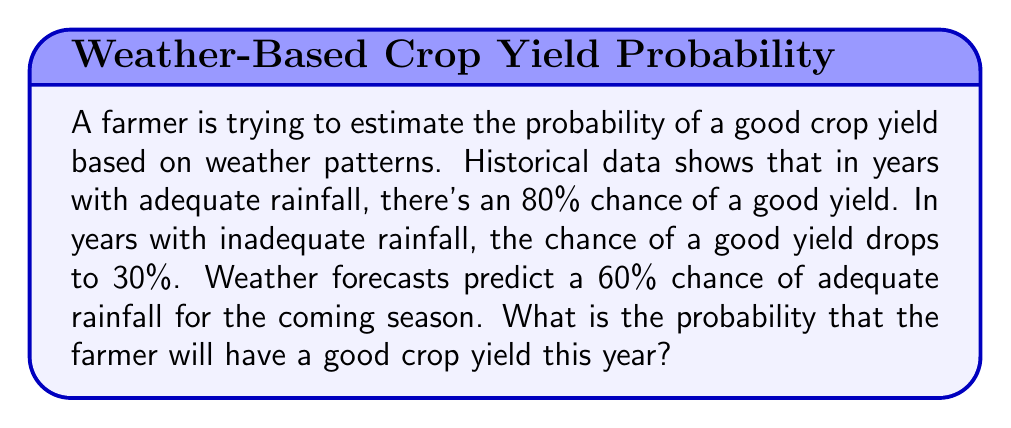What is the answer to this math problem? Let's approach this problem using the law of total probability. We'll define the following events:

A: Adequate rainfall
G: Good crop yield

We're given the following probabilities:
$P(G|A) = 0.80$ (probability of good yield given adequate rainfall)
$P(G|\neg A) = 0.30$ (probability of good yield given inadequate rainfall)
$P(A) = 0.60$ (probability of adequate rainfall)

The law of total probability states:

$$P(G) = P(G|A) \cdot P(A) + P(G|\neg A) \cdot P(\neg A)$$

We know $P(A) = 0.60$, so $P(\neg A) = 1 - P(A) = 0.40$

Now, let's substitute the values into the formula:

$$\begin{align*}
P(G) &= 0.80 \cdot 0.60 + 0.30 \cdot 0.40 \\
&= 0.48 + 0.12 \\
&= 0.60
\end{align*}$$

Therefore, the probability of a good crop yield this year is 0.60 or 60%.
Answer: 0.60 or 60% 